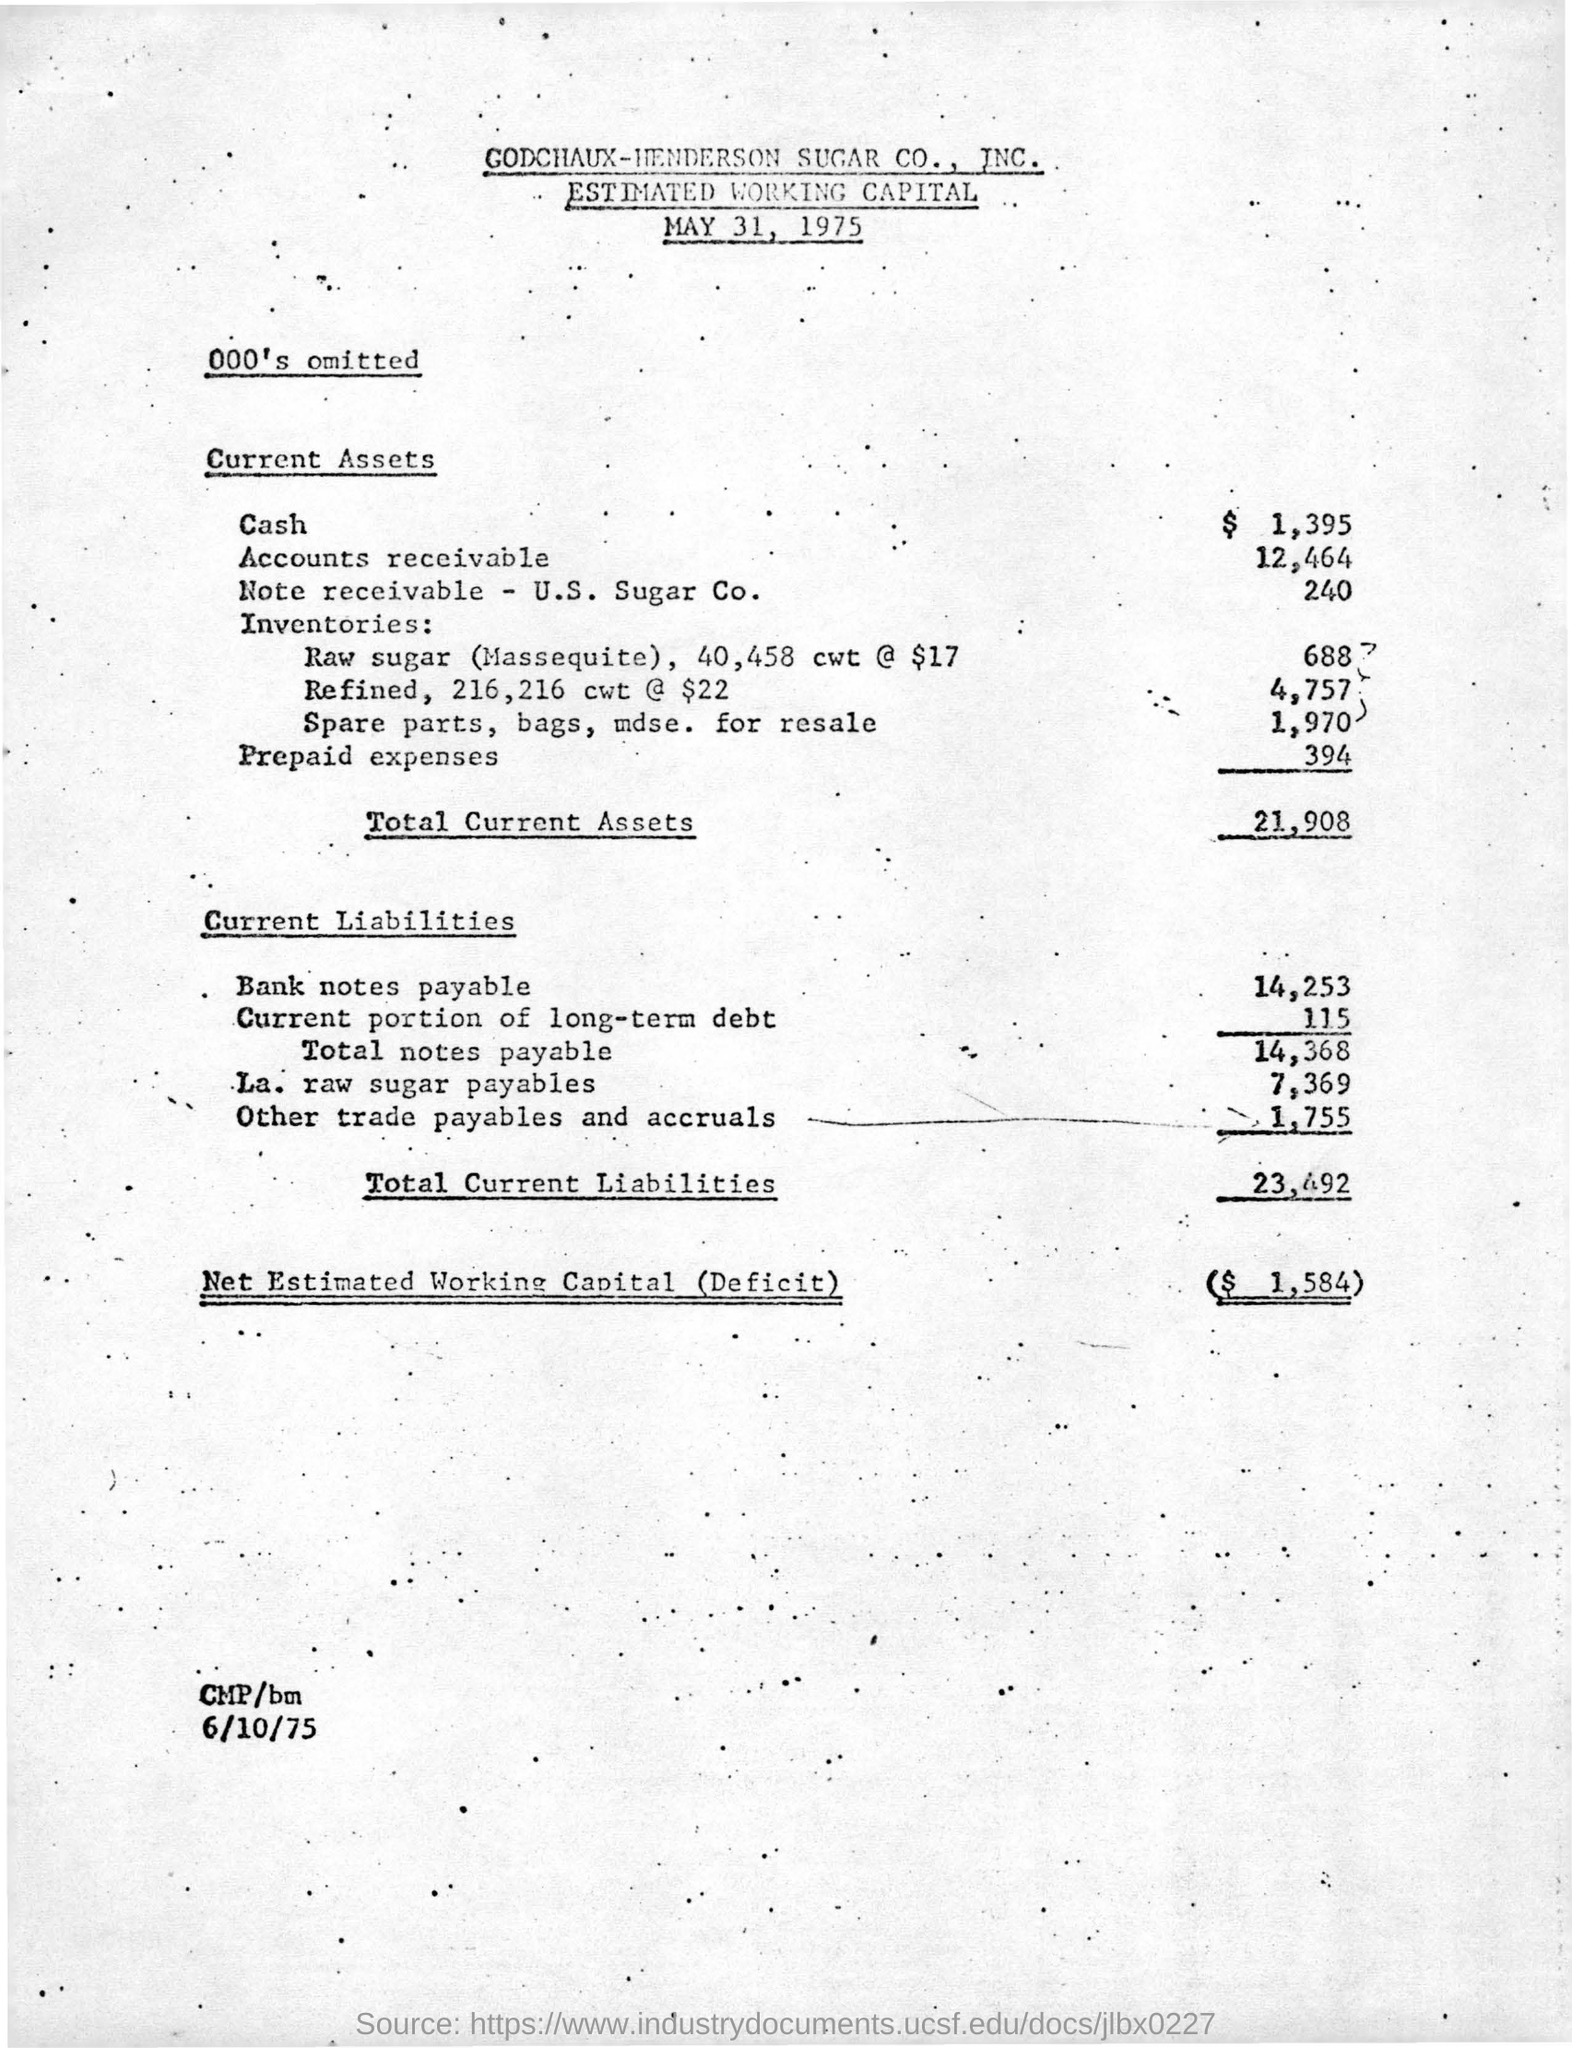Point out several critical features in this image. The estimated working capital deficit is $1,584. The value of other trade payables and accruals in the current liabilities is 1,755. The current assets include prepaid expenses with a total amount of $394. The total current liabilities amount to 23,492. The total current assets amount to 21,908. 